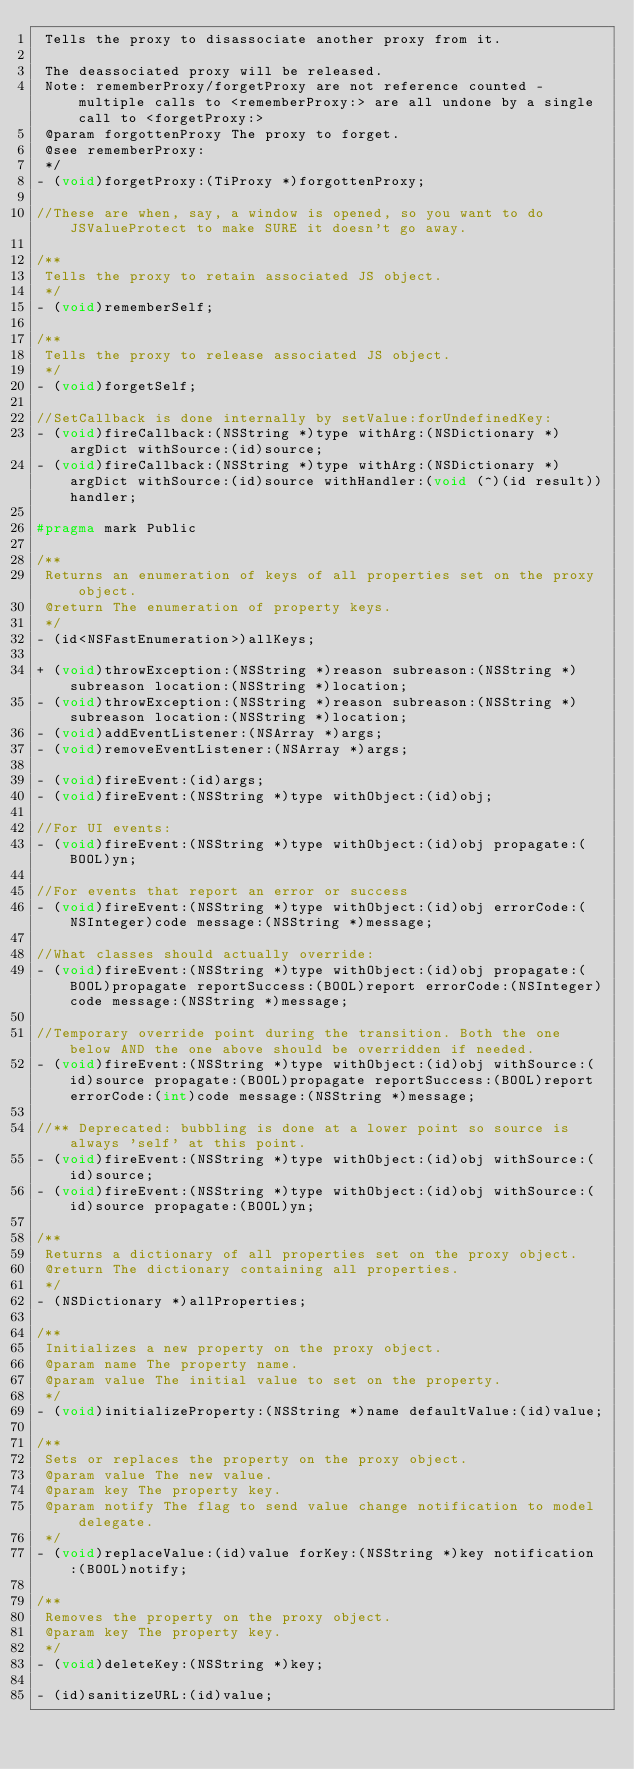<code> <loc_0><loc_0><loc_500><loc_500><_C_> Tells the proxy to disassociate another proxy from it.
 
 The deassociated proxy will be released.
 Note: rememberProxy/forgetProxy are not reference counted - multiple calls to <rememberProxy:> are all undone by a single call to <forgetProxy:> 
 @param forgottenProxy The proxy to forget.
 @see rememberProxy:
 */
- (void)forgetProxy:(TiProxy *)forgottenProxy;

//These are when, say, a window is opened, so you want to do JSValueProtect to make SURE it doesn't go away.

/**
 Tells the proxy to retain associated JS object.
 */
- (void)rememberSelf;

/**
 Tells the proxy to release associated JS object.
 */
- (void)forgetSelf;

//SetCallback is done internally by setValue:forUndefinedKey:
- (void)fireCallback:(NSString *)type withArg:(NSDictionary *)argDict withSource:(id)source;
- (void)fireCallback:(NSString *)type withArg:(NSDictionary *)argDict withSource:(id)source withHandler:(void (^)(id result))handler;

#pragma mark Public

/**
 Returns an enumeration of keys of all properties set on the proxy object.
 @return The enumeration of property keys.
 */
- (id<NSFastEnumeration>)allKeys;

+ (void)throwException:(NSString *)reason subreason:(NSString *)subreason location:(NSString *)location;
- (void)throwException:(NSString *)reason subreason:(NSString *)subreason location:(NSString *)location;
- (void)addEventListener:(NSArray *)args;
- (void)removeEventListener:(NSArray *)args;

- (void)fireEvent:(id)args;
- (void)fireEvent:(NSString *)type withObject:(id)obj;

//For UI events:
- (void)fireEvent:(NSString *)type withObject:(id)obj propagate:(BOOL)yn;

//For events that report an error or success
- (void)fireEvent:(NSString *)type withObject:(id)obj errorCode:(NSInteger)code message:(NSString *)message;

//What classes should actually override:
- (void)fireEvent:(NSString *)type withObject:(id)obj propagate:(BOOL)propagate reportSuccess:(BOOL)report errorCode:(NSInteger)code message:(NSString *)message;

//Temporary override point during the transition. Both the one below AND the one above should be overridden if needed.
- (void)fireEvent:(NSString *)type withObject:(id)obj withSource:(id)source propagate:(BOOL)propagate reportSuccess:(BOOL)report errorCode:(int)code message:(NSString *)message;

//** Deprecated: bubbling is done at a lower point so source is always 'self' at this point.
- (void)fireEvent:(NSString *)type withObject:(id)obj withSource:(id)source;
- (void)fireEvent:(NSString *)type withObject:(id)obj withSource:(id)source propagate:(BOOL)yn;

/**
 Returns a dictionary of all properties set on the proxy object.
 @return The dictionary containing all properties.
 */
- (NSDictionary *)allProperties;

/**
 Initializes a new property on the proxy object.
 @param name The property name.
 @param value The initial value to set on the property.
 */
- (void)initializeProperty:(NSString *)name defaultValue:(id)value;

/**
 Sets or replaces the property on the proxy object.
 @param value The new value.
 @param key The property key.
 @param notify The flag to send value change notification to model delegate.
 */
- (void)replaceValue:(id)value forKey:(NSString *)key notification:(BOOL)notify;

/**
 Removes the property on the proxy object.
 @param key The property key.
 */
- (void)deleteKey:(NSString *)key;

- (id)sanitizeURL:(id)value;
</code> 